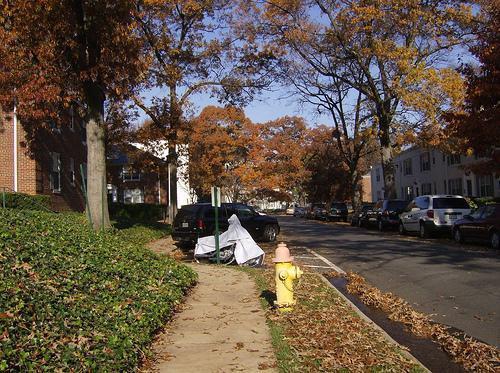How many fire hydrants are there?
Give a very brief answer. 1. How many black trucks are in the picture?
Give a very brief answer. 1. How many cars are in the picture?
Give a very brief answer. 2. 